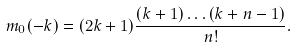Convert formula to latex. <formula><loc_0><loc_0><loc_500><loc_500>m _ { 0 } ( - k ) = ( 2 k + 1 ) \frac { ( k + 1 ) \dots ( k + n - 1 ) } { n ! } .</formula> 